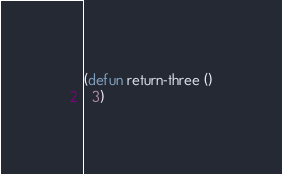<code> <loc_0><loc_0><loc_500><loc_500><_Lisp_>(defun return-three ()
  3)
</code> 